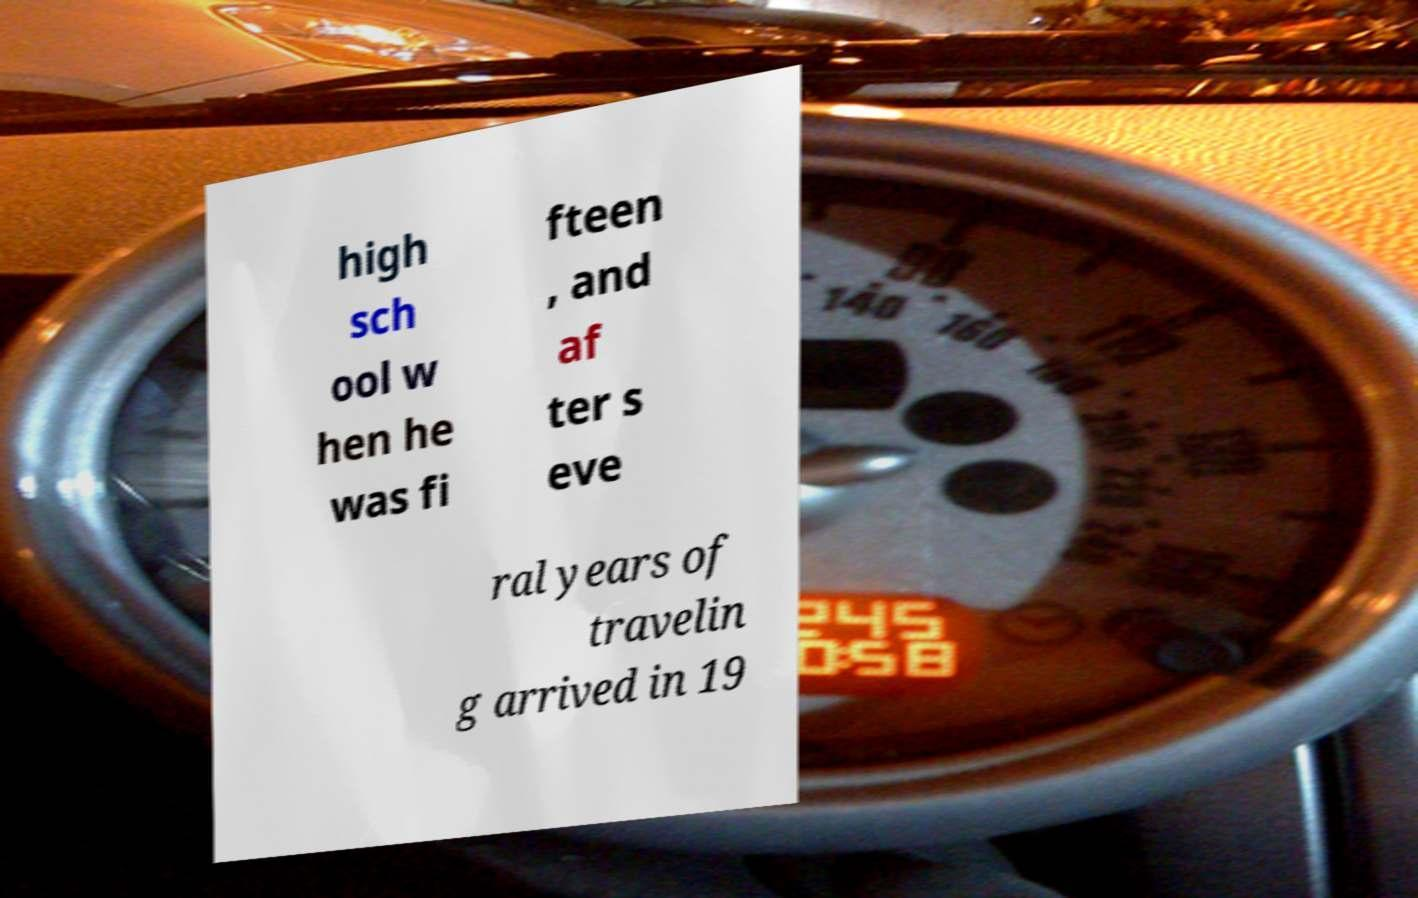Please read and relay the text visible in this image. What does it say? high sch ool w hen he was fi fteen , and af ter s eve ral years of travelin g arrived in 19 